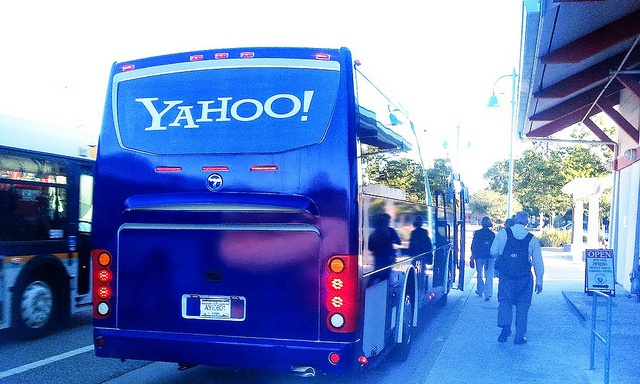Describe the objects in this image and their specific colors. I can see bus in white, darkblue, blue, and navy tones, bus in white, black, navy, and blue tones, people in white, blue, and lightblue tones, backpack in white, blue, lightblue, and darkblue tones, and people in white, blue, lightblue, and lightgray tones in this image. 